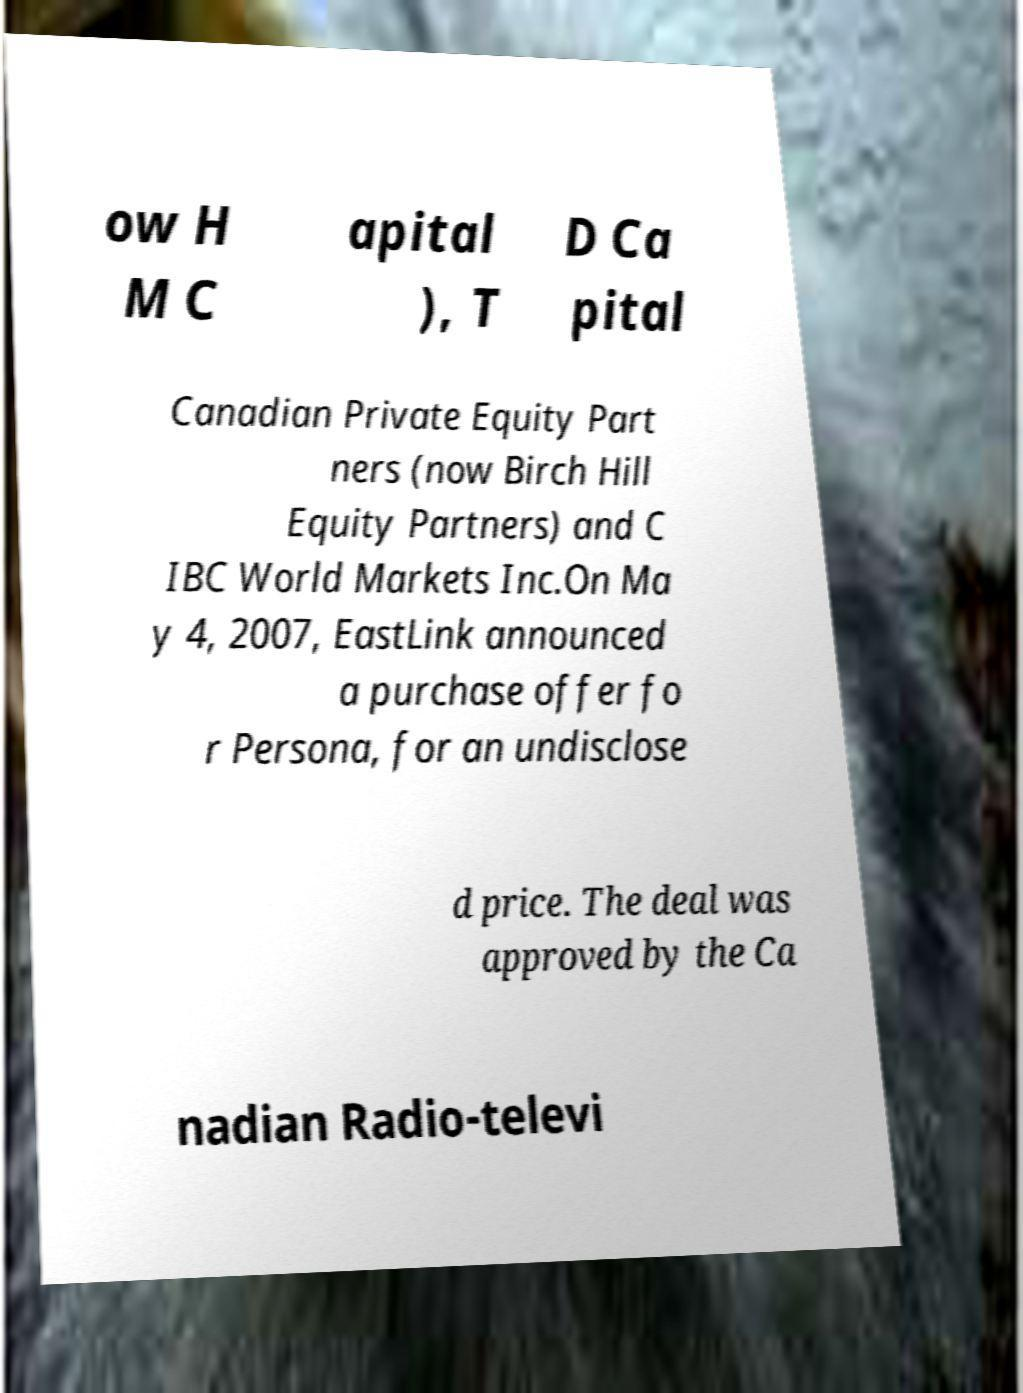Can you accurately transcribe the text from the provided image for me? ow H M C apital ), T D Ca pital Canadian Private Equity Part ners (now Birch Hill Equity Partners) and C IBC World Markets Inc.On Ma y 4, 2007, EastLink announced a purchase offer fo r Persona, for an undisclose d price. The deal was approved by the Ca nadian Radio-televi 